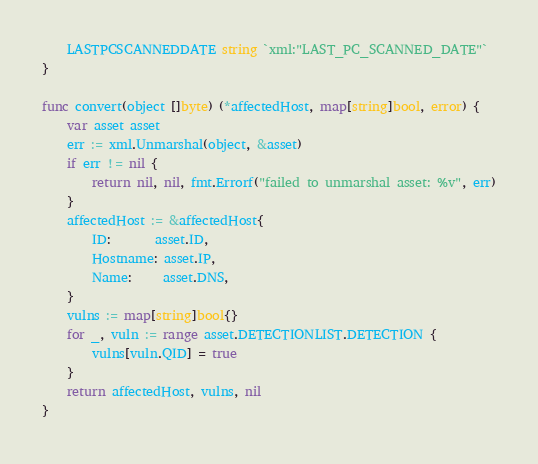<code> <loc_0><loc_0><loc_500><loc_500><_Go_>	LASTPCSCANNEDDATE string `xml:"LAST_PC_SCANNED_DATE"`
}

func convert(object []byte) (*affectedHost, map[string]bool, error) {
	var asset asset
	err := xml.Unmarshal(object, &asset)
	if err != nil {
		return nil, nil, fmt.Errorf("failed to unmarshal asset: %v", err)
	}
	affectedHost := &affectedHost{
		ID:       asset.ID,
		Hostname: asset.IP,
		Name:     asset.DNS,
	}
	vulns := map[string]bool{}
	for _, vuln := range asset.DETECTIONLIST.DETECTION {
		vulns[vuln.QID] = true
	}
	return affectedHost, vulns, nil
}
</code> 